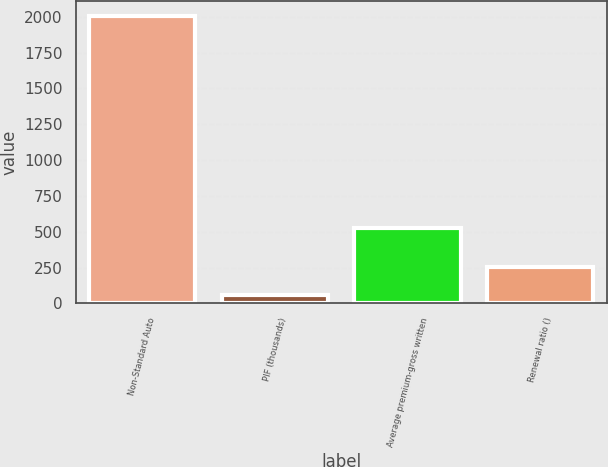Convert chart to OTSL. <chart><loc_0><loc_0><loc_500><loc_500><bar_chart><fcel>Non-Standard Auto<fcel>PIF (thousands)<fcel>Average premium-gross written<fcel>Renewal ratio ()<nl><fcel>2007<fcel>56<fcel>526<fcel>251.1<nl></chart> 